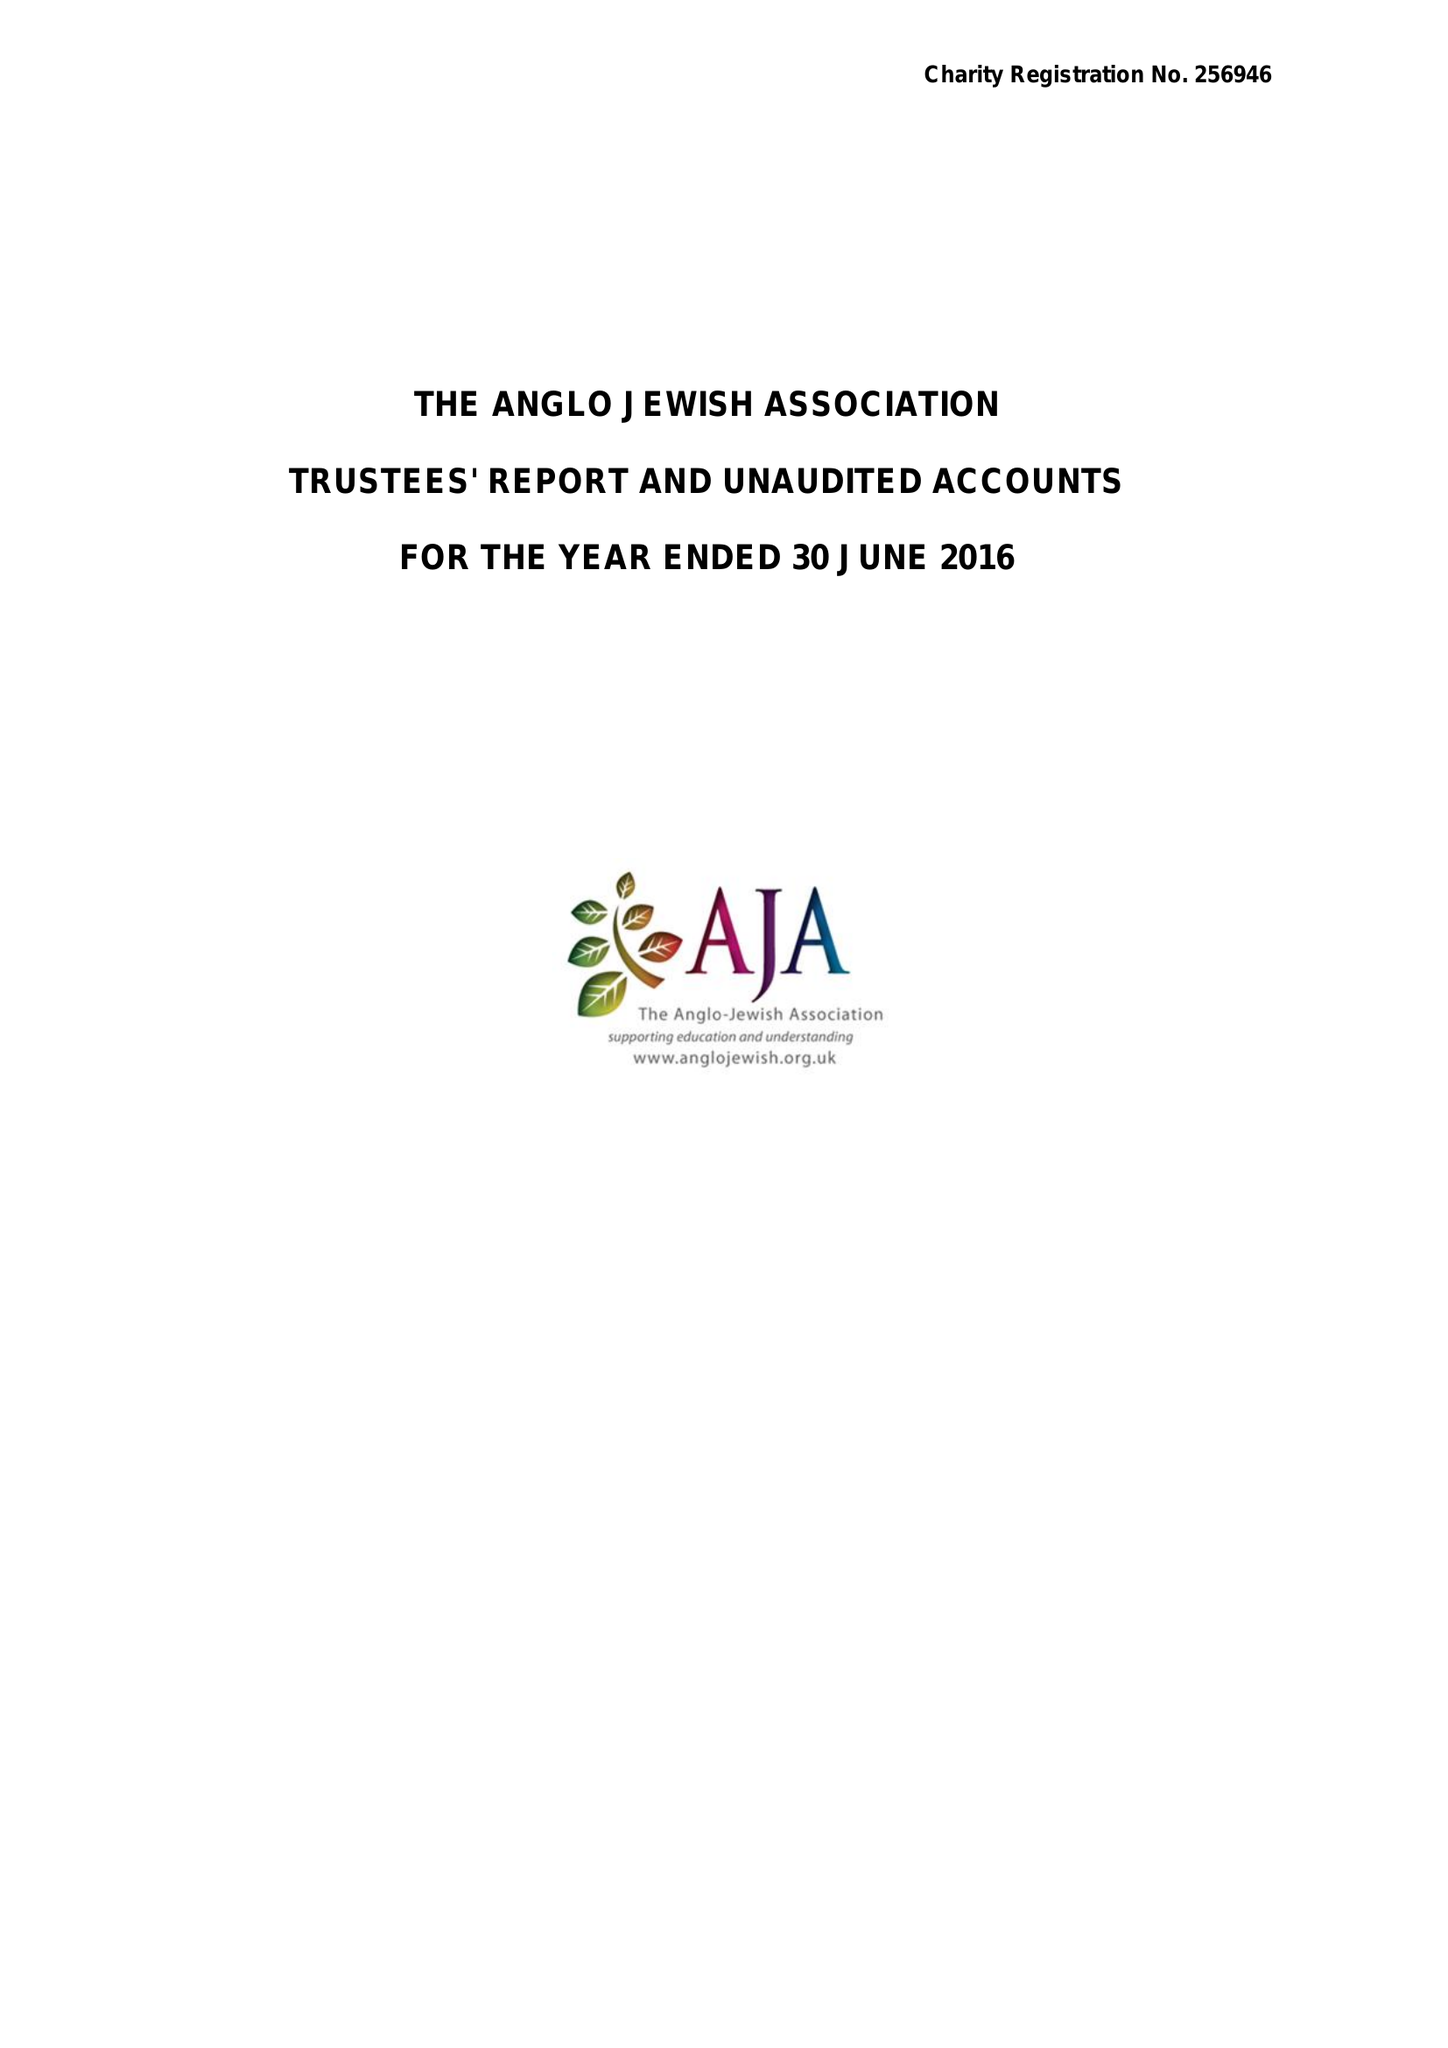What is the value for the income_annually_in_british_pounds?
Answer the question using a single word or phrase. 31781.00 